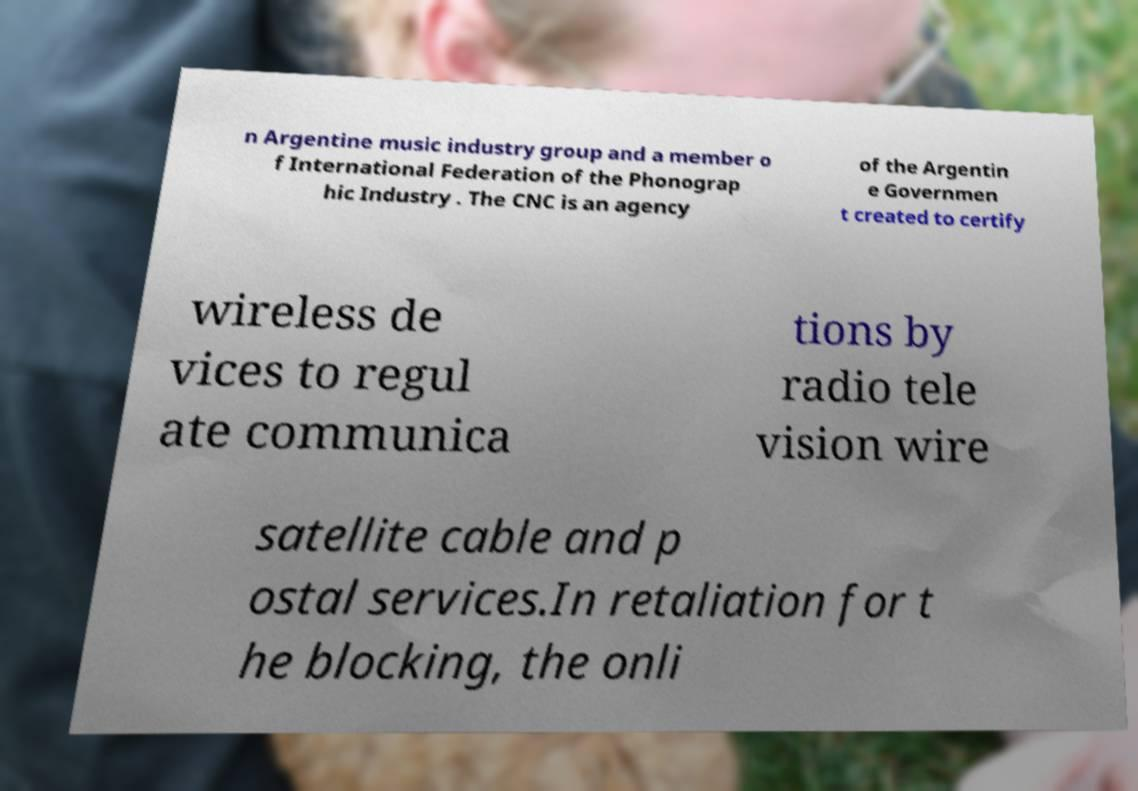For documentation purposes, I need the text within this image transcribed. Could you provide that? n Argentine music industry group and a member o f International Federation of the Phonograp hic Industry . The CNC is an agency of the Argentin e Governmen t created to certify wireless de vices to regul ate communica tions by radio tele vision wire satellite cable and p ostal services.In retaliation for t he blocking, the onli 